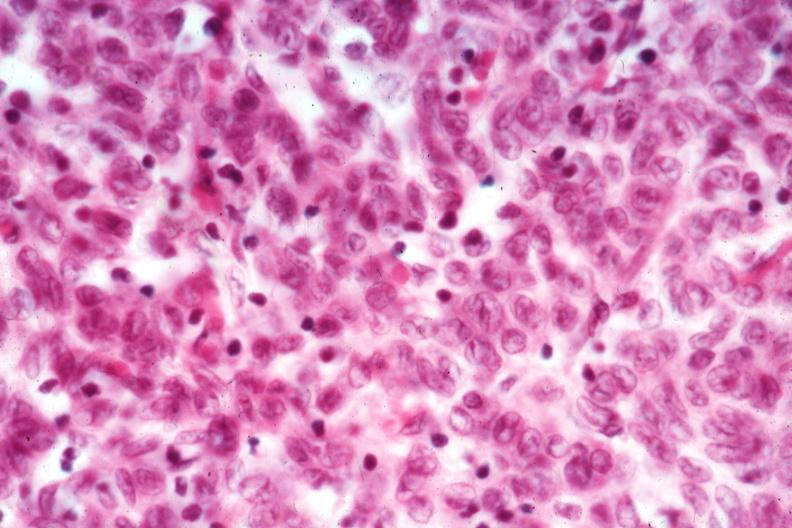s carcinoma metastatic lung present?
Answer the question using a single word or phrase. No 